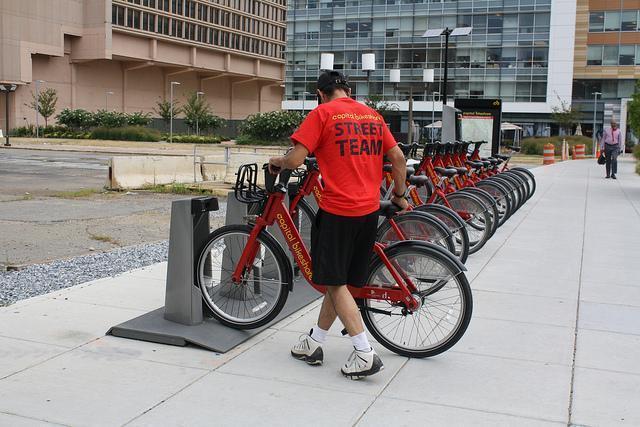What is the man standing next to the bikes most likely doing?
Indicate the correct response and explain using: 'Answer: answer
Rationale: rationale.'
Options: Travelling, exercising, training, working. Answer: working.
Rationale: The man's shirt has the same company name on it as the bike does.  he is putting the bike away as part of his duties as an employee. 